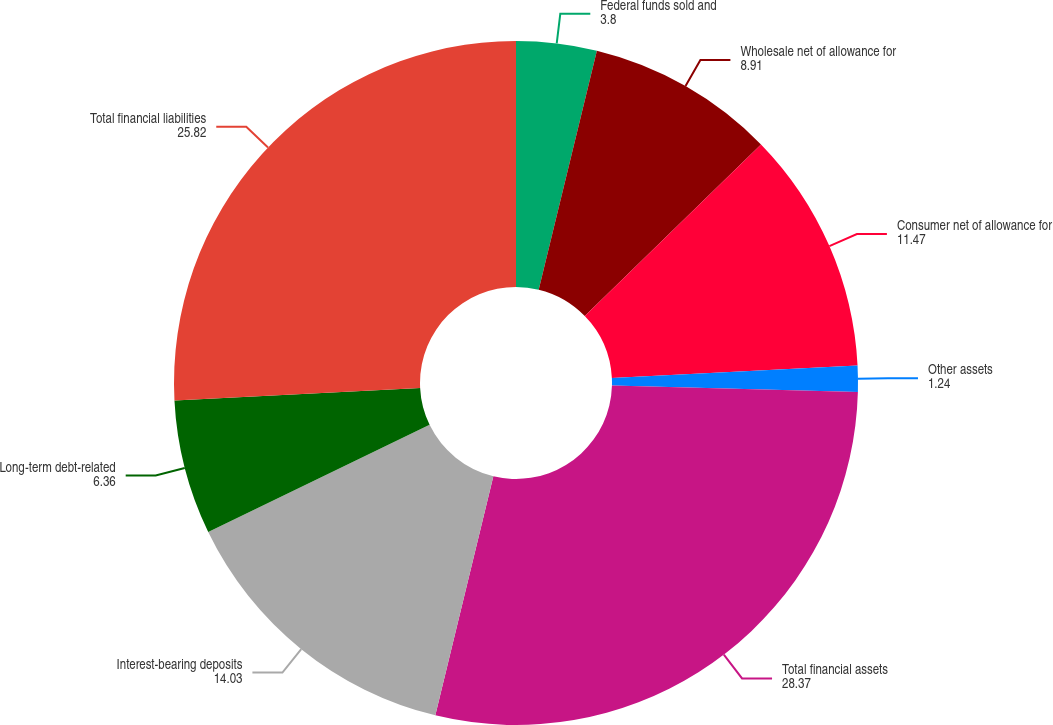Convert chart to OTSL. <chart><loc_0><loc_0><loc_500><loc_500><pie_chart><fcel>Federal funds sold and<fcel>Wholesale net of allowance for<fcel>Consumer net of allowance for<fcel>Other assets<fcel>Total financial assets<fcel>Interest-bearing deposits<fcel>Long-term debt-related<fcel>Total financial liabilities<nl><fcel>3.8%<fcel>8.91%<fcel>11.47%<fcel>1.24%<fcel>28.37%<fcel>14.03%<fcel>6.36%<fcel>25.82%<nl></chart> 